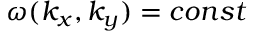<formula> <loc_0><loc_0><loc_500><loc_500>\omega ( k _ { x } , k _ { y } ) = c o n s t</formula> 